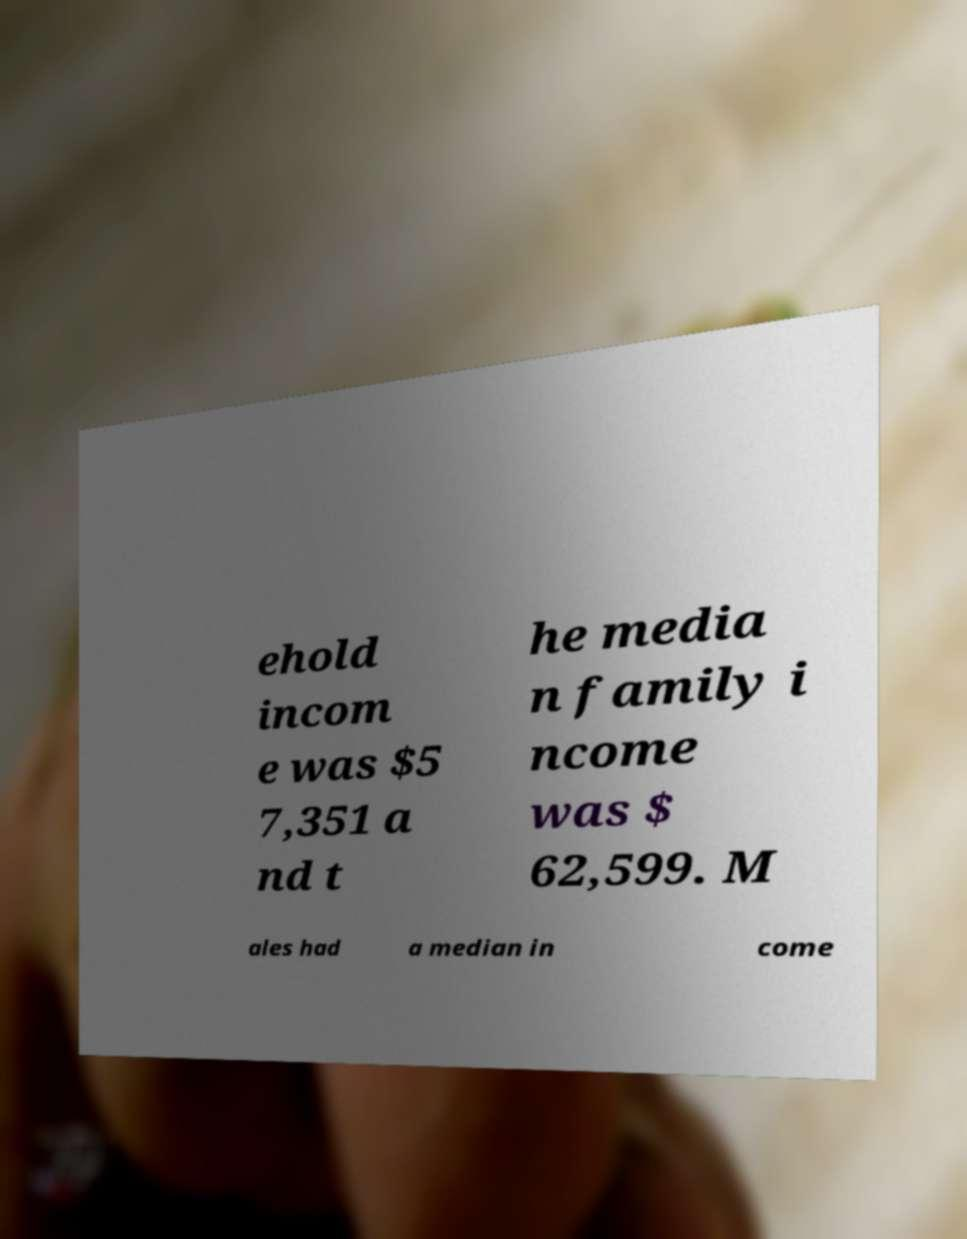Please read and relay the text visible in this image. What does it say? ehold incom e was $5 7,351 a nd t he media n family i ncome was $ 62,599. M ales had a median in come 